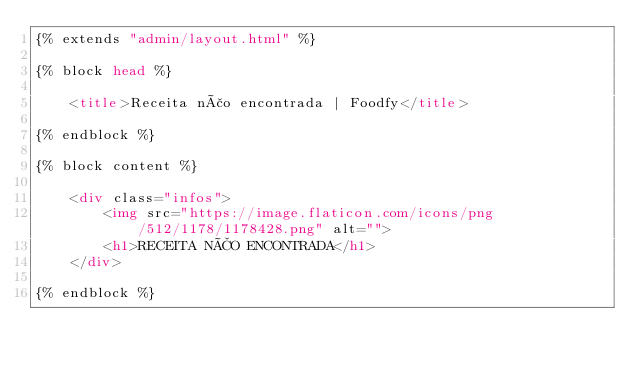Convert code to text. <code><loc_0><loc_0><loc_500><loc_500><_HTML_>{% extends "admin/layout.html" %}

{% block head %}

    <title>Receita não encontrada | Foodfy</title>

{% endblock %}

{% block content %}

    <div class="infos">
        <img src="https://image.flaticon.com/icons/png/512/1178/1178428.png" alt="">
        <h1>RECEITA NÃO ENCONTRADA</h1>
    </div>

{% endblock %}
</code> 